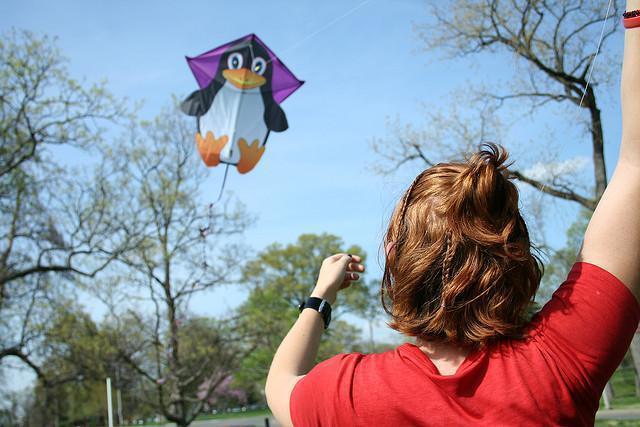How many baby elephants are there?
Give a very brief answer. 0. 